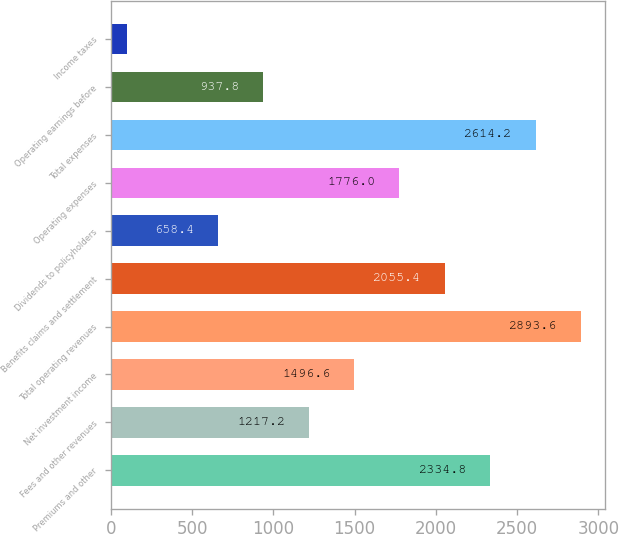Convert chart to OTSL. <chart><loc_0><loc_0><loc_500><loc_500><bar_chart><fcel>Premiums and other<fcel>Fees and other revenues<fcel>Net investment income<fcel>Total operating revenues<fcel>Benefits claims and settlement<fcel>Dividends to policyholders<fcel>Operating expenses<fcel>Total expenses<fcel>Operating earnings before<fcel>Income taxes<nl><fcel>2334.8<fcel>1217.2<fcel>1496.6<fcel>2893.6<fcel>2055.4<fcel>658.4<fcel>1776<fcel>2614.2<fcel>937.8<fcel>99.6<nl></chart> 